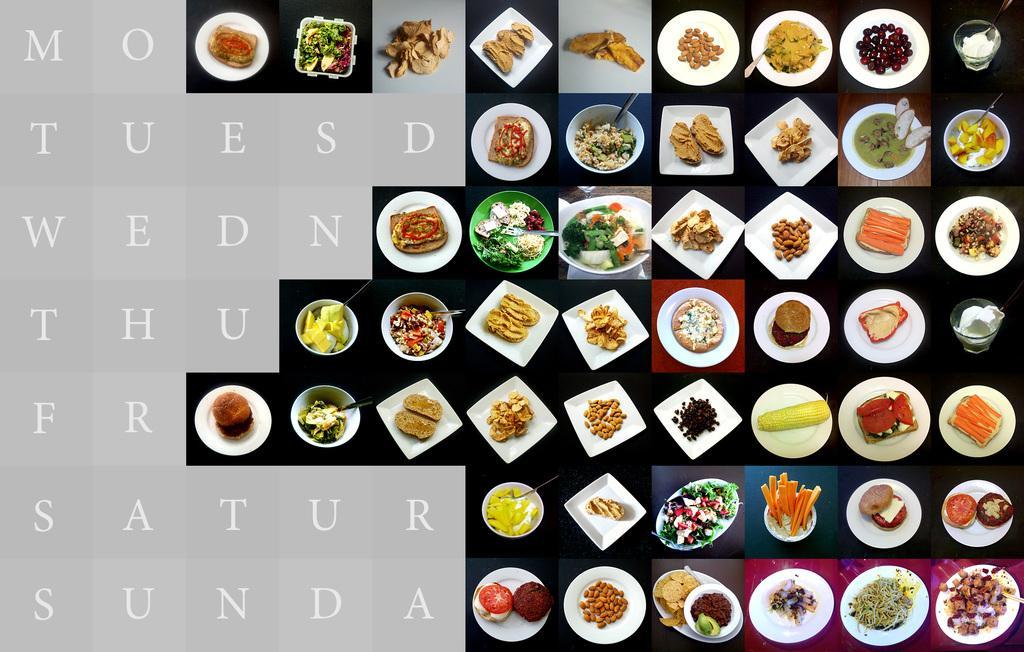Please provide a concise description of this image. In the image we can see a poster. In the poster we can see some plates, bowls, food and alphabets. 